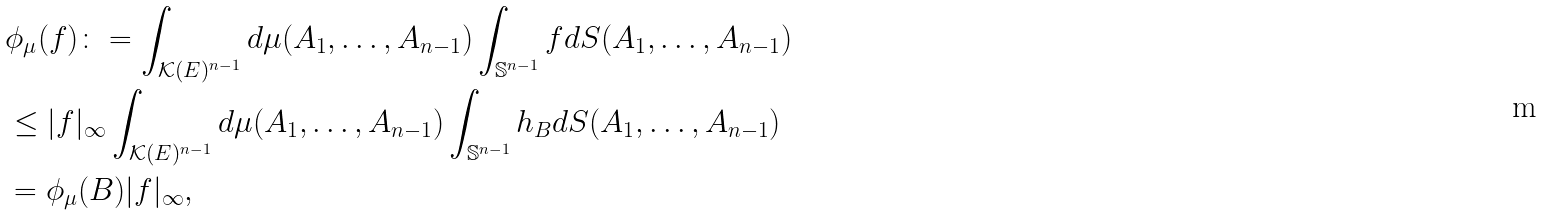Convert formula to latex. <formula><loc_0><loc_0><loc_500><loc_500>& \phi _ { \mu } ( f ) \colon = \int _ { \mathcal { K } ( E ) ^ { n - 1 } } d \mu ( A _ { 1 } , \dots , A _ { n - 1 } ) \int _ { \mathbb { S } ^ { n - 1 } } f d S ( A _ { 1 } , \dots , A _ { n - 1 } ) \\ & \leq | f | _ { \infty } \int _ { \mathcal { K } ( E ) ^ { n - 1 } } d \mu ( A _ { 1 } , \dots , A _ { n - 1 } ) \int _ { \mathbb { S } ^ { n - 1 } } h _ { B } d S ( A _ { 1 } , \dots , A _ { n - 1 } ) \\ & = \phi _ { \mu } ( B ) | f | _ { \infty } ,</formula> 